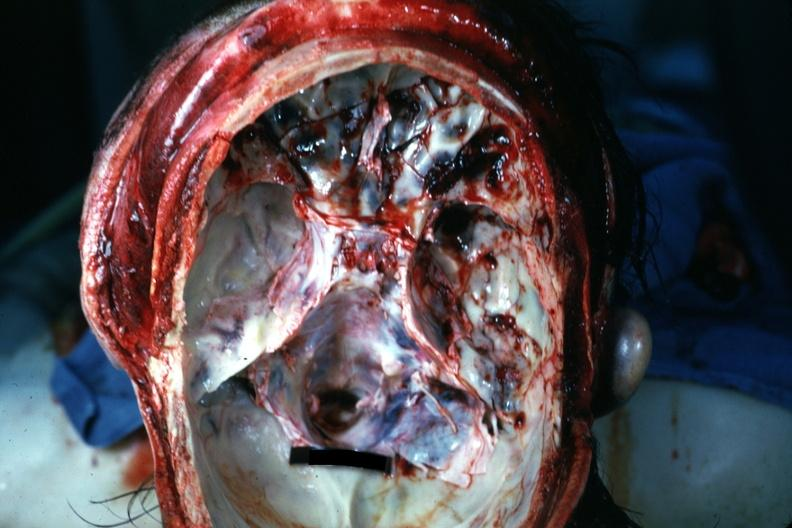s basilar skull fracture present?
Answer the question using a single word or phrase. Yes 